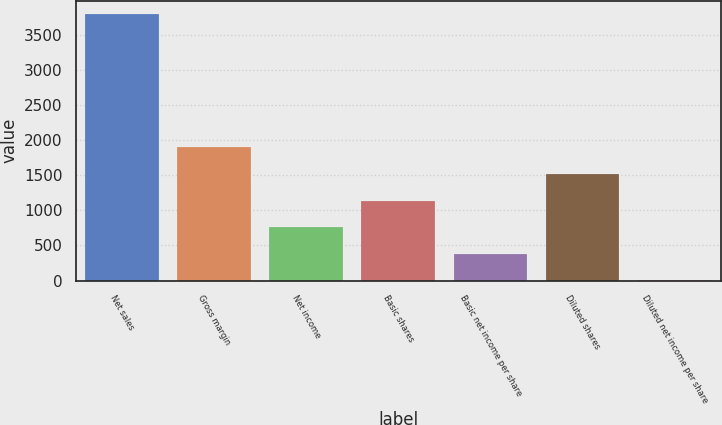Convert chart. <chart><loc_0><loc_0><loc_500><loc_500><bar_chart><fcel>Net sales<fcel>Gross margin<fcel>Net income<fcel>Basic shares<fcel>Basic net income per share<fcel>Diluted shares<fcel>Diluted net income per share<nl><fcel>3804<fcel>1902.27<fcel>761.22<fcel>1141.57<fcel>380.87<fcel>1521.92<fcel>0.52<nl></chart> 